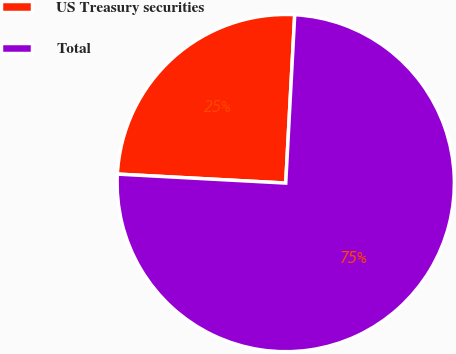Convert chart. <chart><loc_0><loc_0><loc_500><loc_500><pie_chart><fcel>US Treasury securities<fcel>Total<nl><fcel>25.0%<fcel>75.0%<nl></chart> 